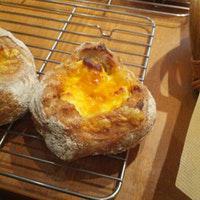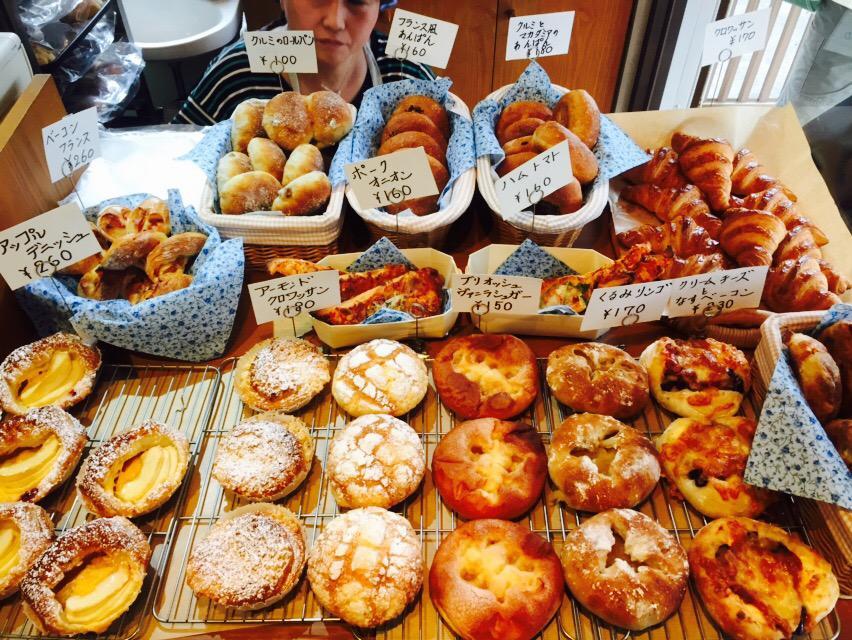The first image is the image on the left, the second image is the image on the right. Analyze the images presented: Is the assertion "One image contains exactly two round roll-type items displayed horizontally and side-by-side." valid? Answer yes or no. Yes. The first image is the image on the left, the second image is the image on the right. Evaluate the accuracy of this statement regarding the images: "There are no more than five pastries.". Is it true? Answer yes or no. No. 